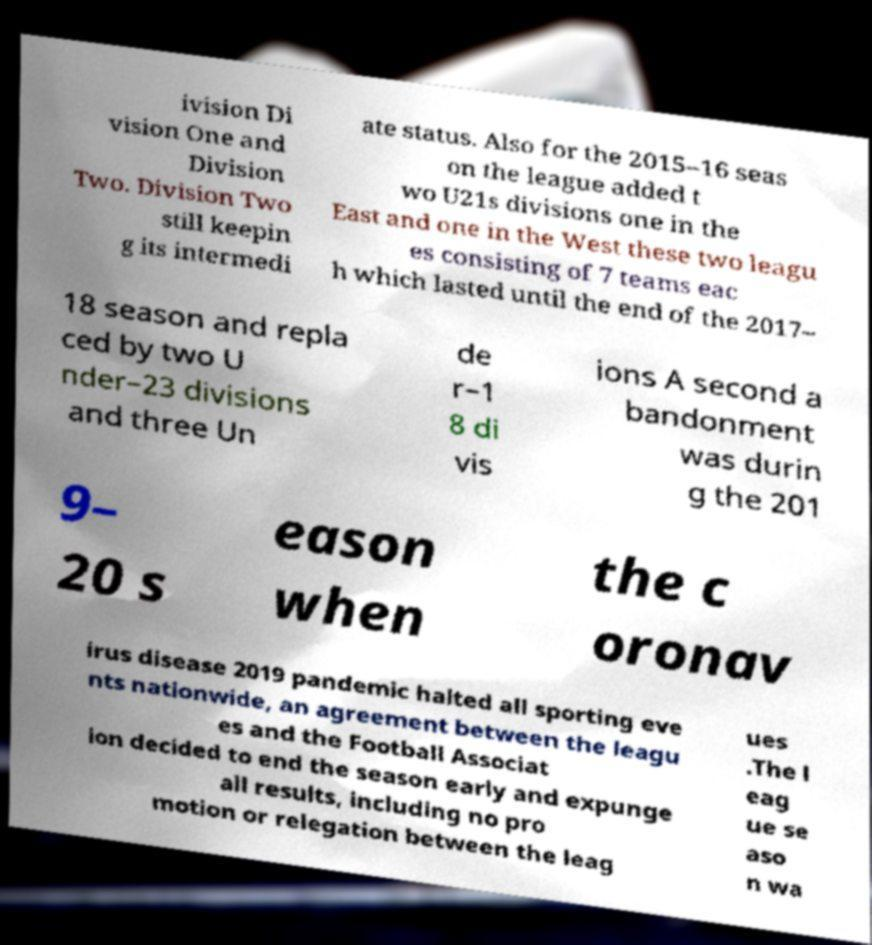Please read and relay the text visible in this image. What does it say? ivision Di vision One and Division Two. Division Two still keepin g its intermedi ate status. Also for the 2015–16 seas on the league added t wo U21s divisions one in the East and one in the West these two leagu es consisting of 7 teams eac h which lasted until the end of the 2017– 18 season and repla ced by two U nder–23 divisions and three Un de r–1 8 di vis ions A second a bandonment was durin g the 201 9– 20 s eason when the c oronav irus disease 2019 pandemic halted all sporting eve nts nationwide, an agreement between the leagu es and the Football Associat ion decided to end the season early and expunge all results, including no pro motion or relegation between the leag ues .The l eag ue se aso n wa 